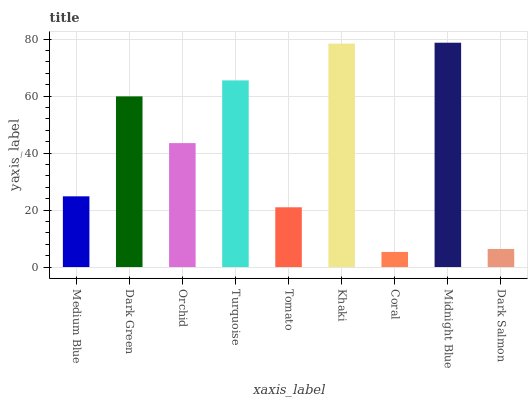Is Coral the minimum?
Answer yes or no. Yes. Is Midnight Blue the maximum?
Answer yes or no. Yes. Is Dark Green the minimum?
Answer yes or no. No. Is Dark Green the maximum?
Answer yes or no. No. Is Dark Green greater than Medium Blue?
Answer yes or no. Yes. Is Medium Blue less than Dark Green?
Answer yes or no. Yes. Is Medium Blue greater than Dark Green?
Answer yes or no. No. Is Dark Green less than Medium Blue?
Answer yes or no. No. Is Orchid the high median?
Answer yes or no. Yes. Is Orchid the low median?
Answer yes or no. Yes. Is Dark Green the high median?
Answer yes or no. No. Is Midnight Blue the low median?
Answer yes or no. No. 